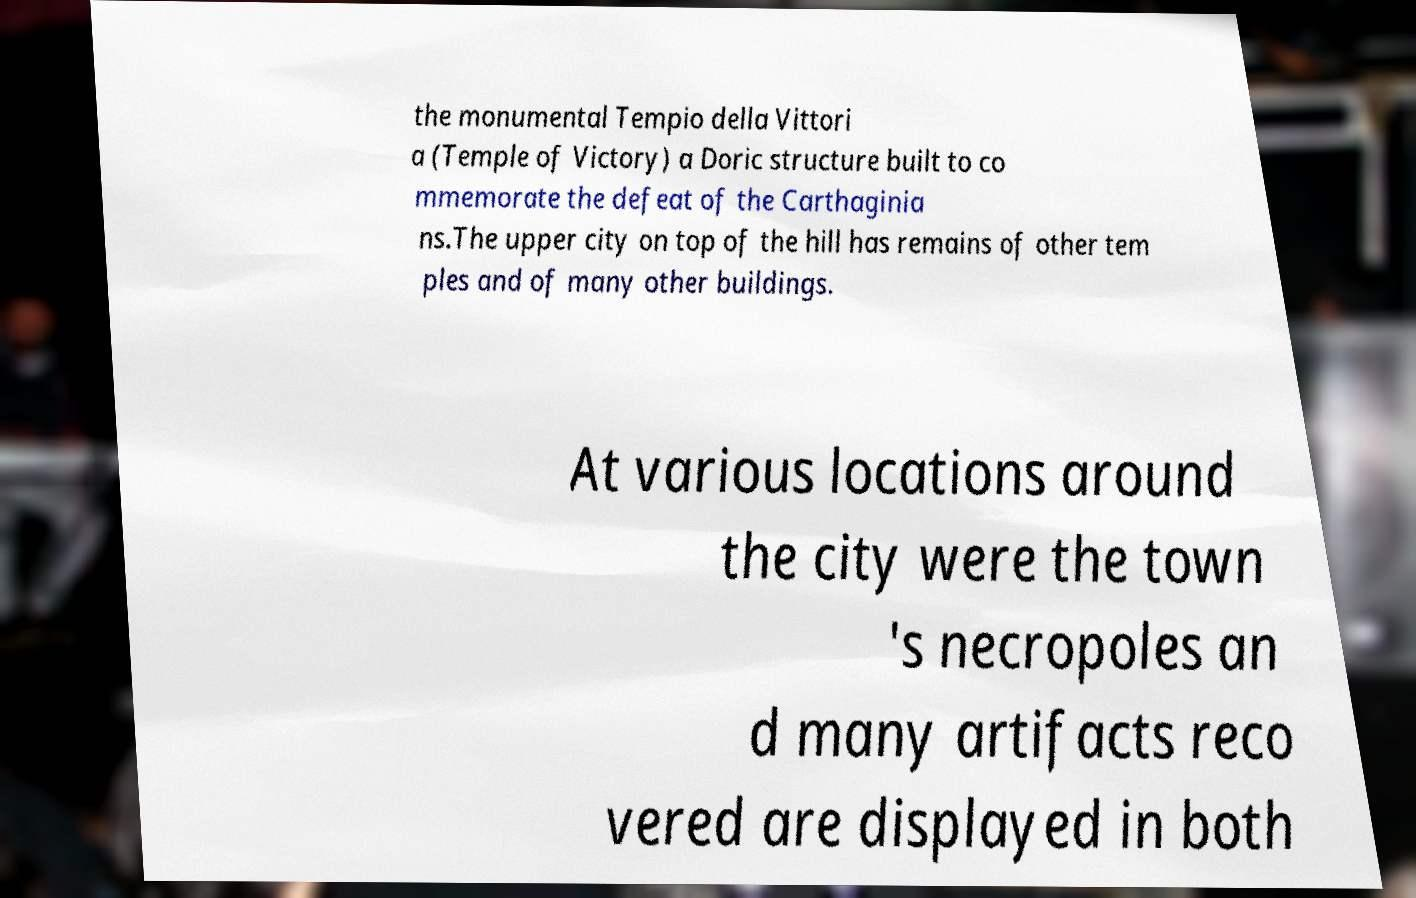I need the written content from this picture converted into text. Can you do that? the monumental Tempio della Vittori a (Temple of Victory) a Doric structure built to co mmemorate the defeat of the Carthaginia ns.The upper city on top of the hill has remains of other tem ples and of many other buildings. At various locations around the city were the town 's necropoles an d many artifacts reco vered are displayed in both 